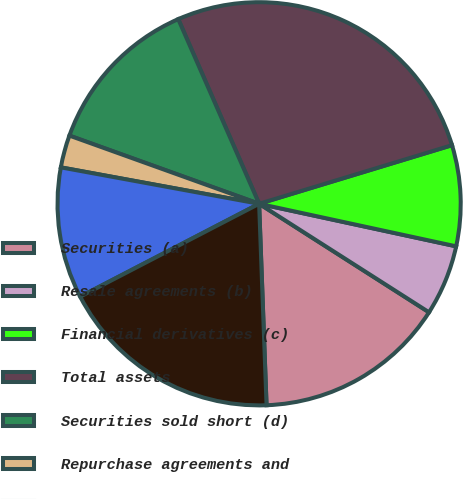<chart> <loc_0><loc_0><loc_500><loc_500><pie_chart><fcel>Securities (a)<fcel>Resale agreements (b)<fcel>Financial derivatives (c)<fcel>Total assets<fcel>Securities sold short (d)<fcel>Repurchase agreements and<fcel>Financial derivatives (f)<fcel>Total liabilities<nl><fcel>15.37%<fcel>5.66%<fcel>8.08%<fcel>26.88%<fcel>12.94%<fcel>2.6%<fcel>10.51%<fcel>17.97%<nl></chart> 